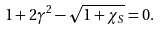<formula> <loc_0><loc_0><loc_500><loc_500>& 1 + 2 \gamma ^ { 2 } - \sqrt { 1 + \chi _ { S } } = 0 .</formula> 